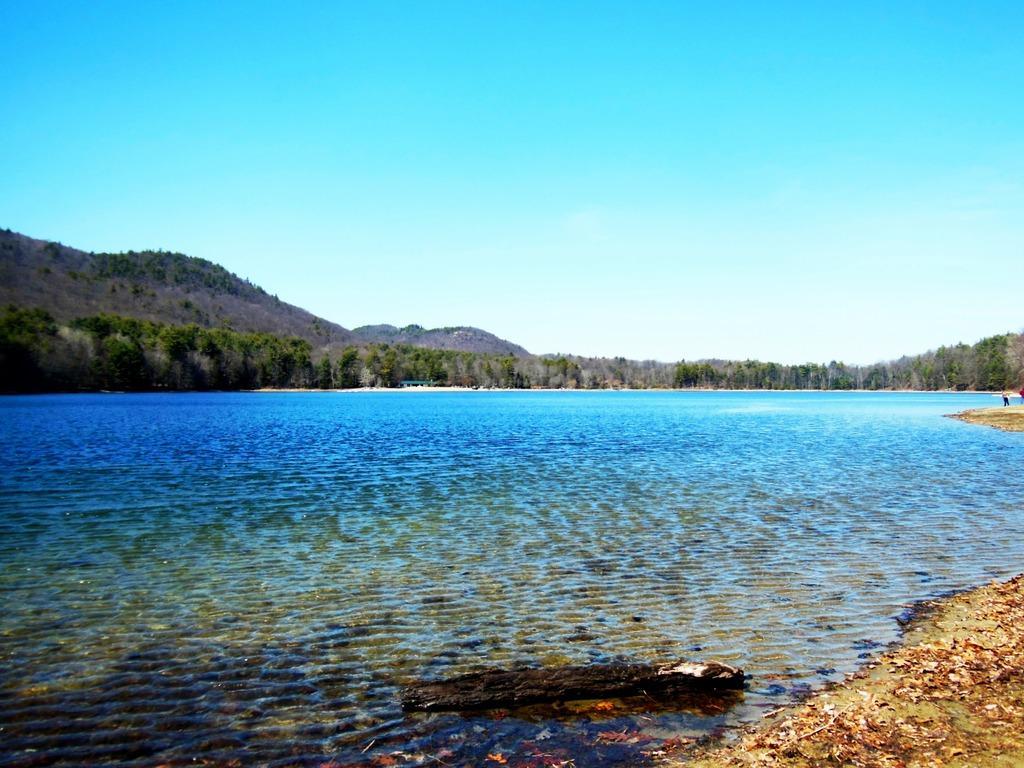How would you summarize this image in a sentence or two? In this image there is a river, in the background trees, mountains and a blue sky. 